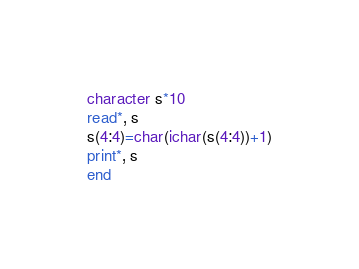Convert code to text. <code><loc_0><loc_0><loc_500><loc_500><_FORTRAN_>character s*10
read*, s
s(4:4)=char(ichar(s(4:4))+1)
print*, s
end</code> 